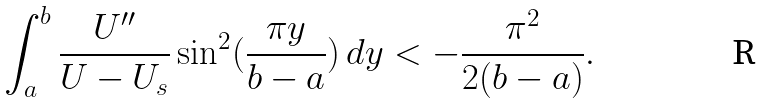<formula> <loc_0><loc_0><loc_500><loc_500>\int _ { a } ^ { b } \frac { U ^ { \prime \prime } } { U - U _ { s } } \sin ^ { 2 } ( \frac { \pi y } { b - a } ) \, d y < - \frac { \pi ^ { 2 } } { 2 ( b - a ) } .</formula> 